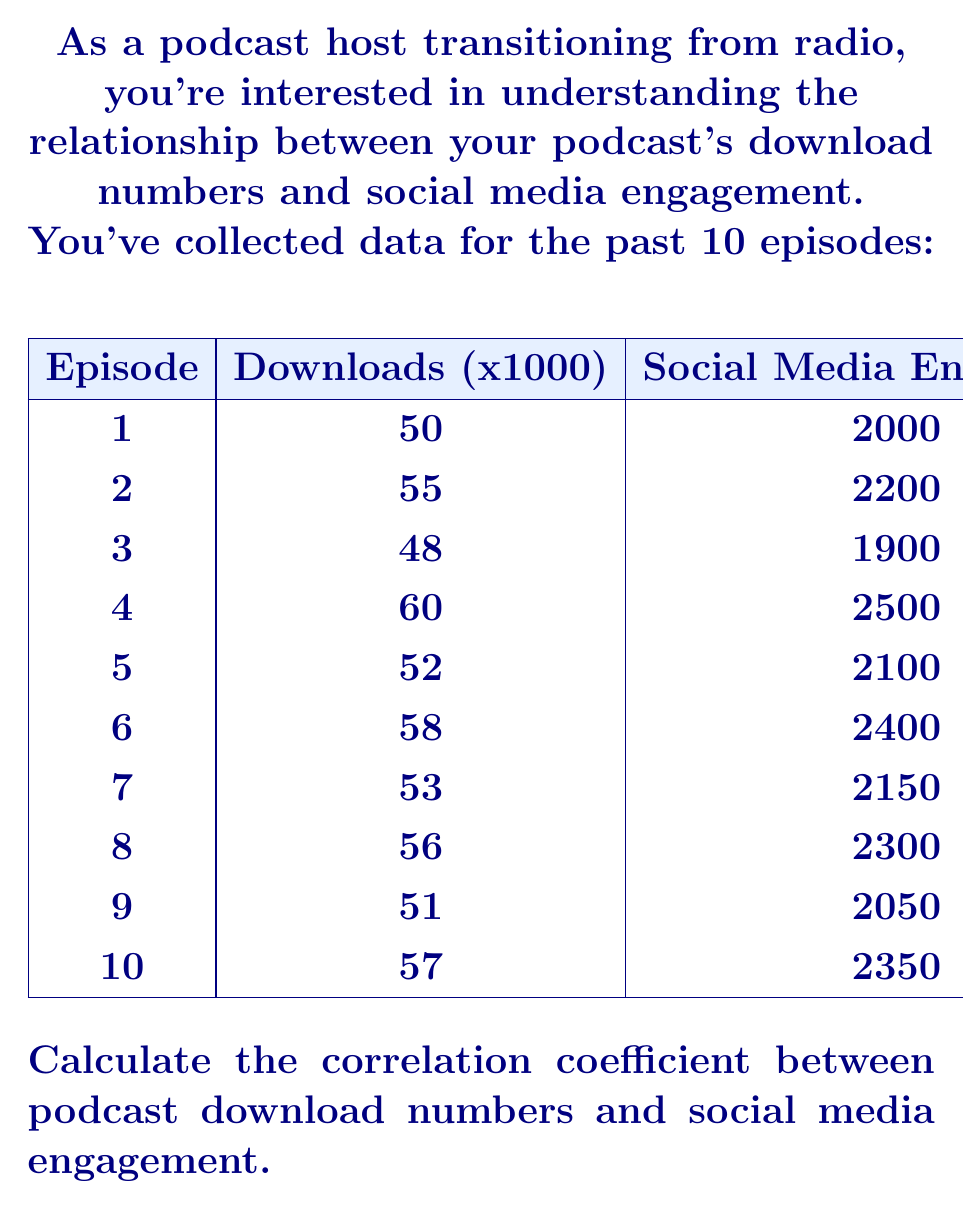Give your solution to this math problem. To calculate the correlation coefficient, we'll use the Pearson correlation formula:

$$ r = \frac{n\sum xy - \sum x \sum y}{\sqrt{[n\sum x^2 - (\sum x)^2][n\sum y^2 - (\sum y)^2]}} $$

Where:
$n$ = number of data points
$x$ = podcast downloads (in thousands)
$y$ = social media engagement

Step 1: Calculate the sums and squares:
$n = 10$
$\sum x = 540$
$\sum y = 21950$
$\sum xy = 1188500$
$\sum x^2 = 29354$
$\sum y^2 = 48372500$

Step 2: Apply the formula:

$$ r = \frac{10(1188500) - (540)(21950)}{\sqrt{[10(29354) - 540^2][10(48372500) - 21950^2]}} $$

Step 3: Simplify:

$$ r = \frac{11885000 - 11853000}{\sqrt{(293540 - 291600)(483725000 - 481802500)}} $$

$$ r = \frac{32000}{\sqrt{(1940)(1922500)}} $$

$$ r = \frac{32000}{\sqrt{3729650000}} $$

$$ r = \frac{32000}{61070.82} $$

Step 4: Calculate the final result:

$$ r \approx 0.5239 $$
Answer: $0.5239$ 